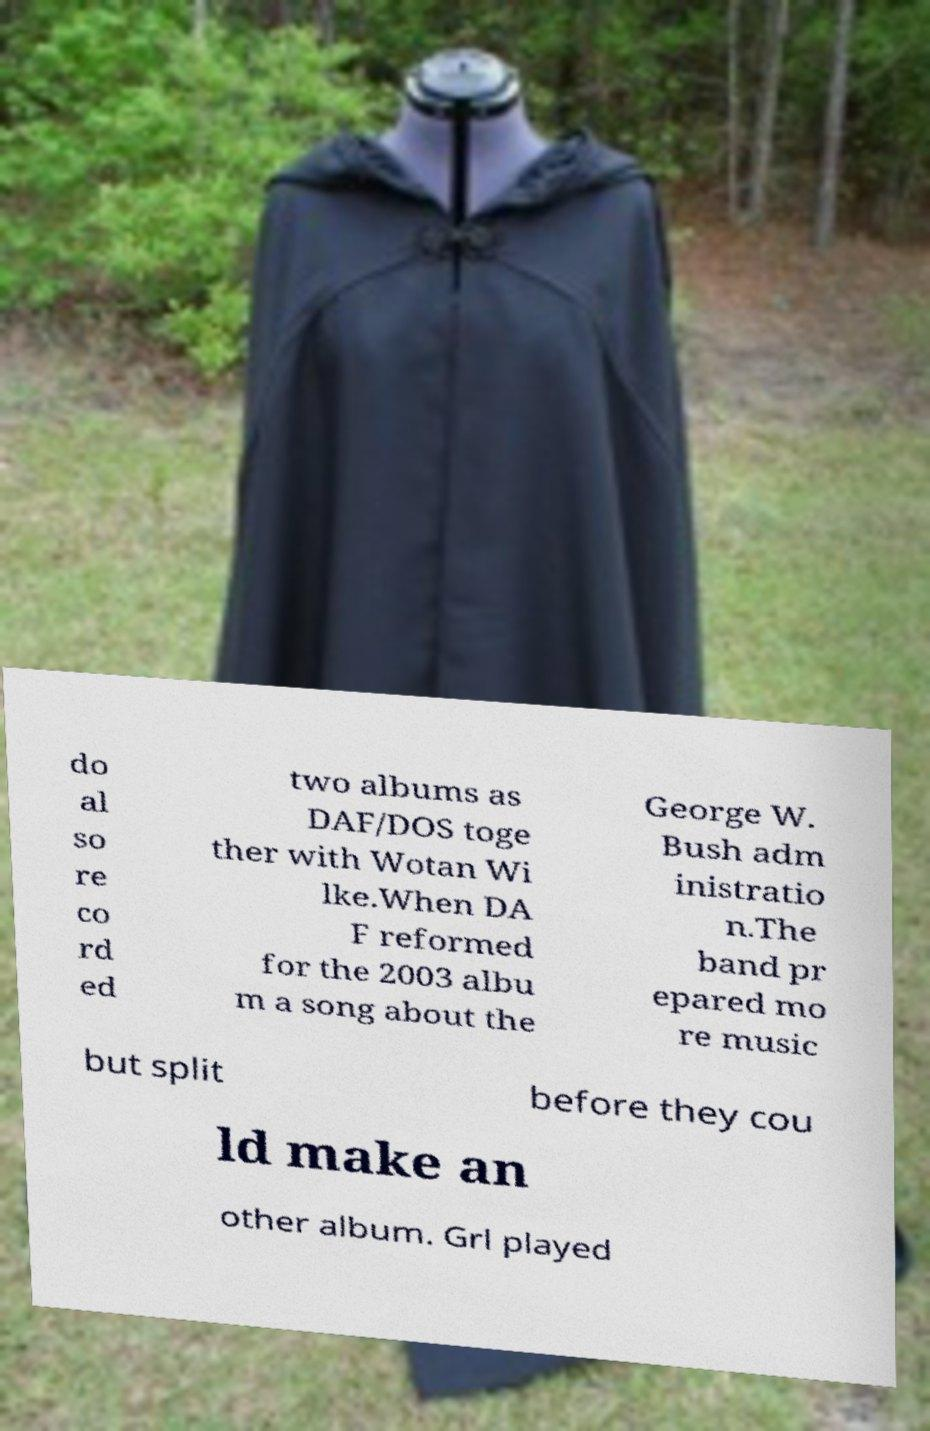I need the written content from this picture converted into text. Can you do that? do al so re co rd ed two albums as DAF/DOS toge ther with Wotan Wi lke.When DA F reformed for the 2003 albu m a song about the George W. Bush adm inistratio n.The band pr epared mo re music but split before they cou ld make an other album. Grl played 